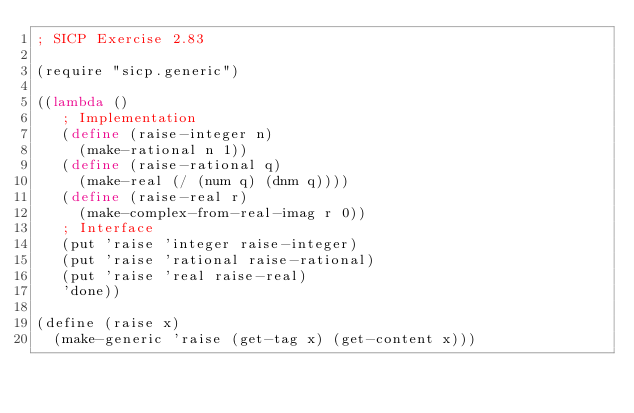<code> <loc_0><loc_0><loc_500><loc_500><_Scheme_>; SICP Exercise 2.83

(require "sicp.generic")

((lambda ()
   ; Implementation
   (define (raise-integer n)
     (make-rational n 1))
   (define (raise-rational q)
     (make-real (/ (num q) (dnm q))))
   (define (raise-real r)
     (make-complex-from-real-imag r 0))
   ; Interface
   (put 'raise 'integer raise-integer)
   (put 'raise 'rational raise-rational)
   (put 'raise 'real raise-real)
   'done))

(define (raise x)
  (make-generic 'raise (get-tag x) (get-content x)))
</code> 